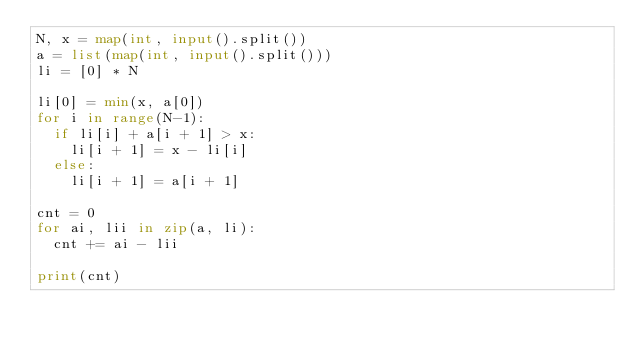<code> <loc_0><loc_0><loc_500><loc_500><_Python_>N, x = map(int, input().split())
a = list(map(int, input().split()))
li = [0] * N

li[0] = min(x, a[0])
for i in range(N-1):
  if li[i] + a[i + 1] > x:
    li[i + 1] = x - li[i]
  else:
    li[i + 1] = a[i + 1]
    
cnt = 0
for ai, lii in zip(a, li):
  cnt += ai - lii

print(cnt)</code> 